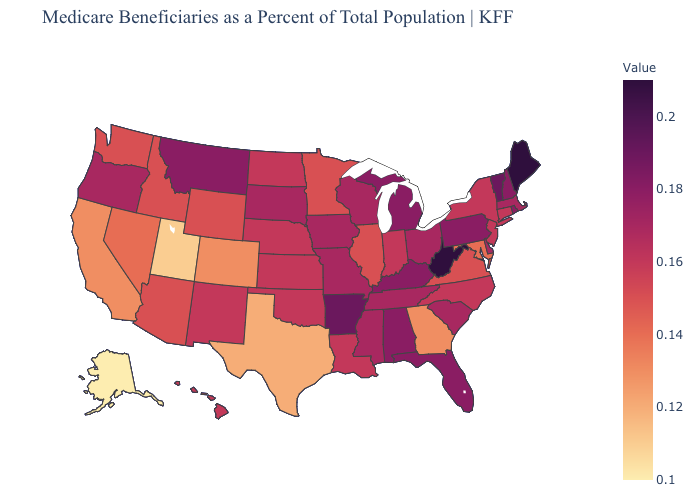Does Indiana have a higher value than Arkansas?
Concise answer only. No. Among the states that border Kentucky , does Ohio have the lowest value?
Answer briefly. No. Among the states that border Arizona , which have the highest value?
Concise answer only. New Mexico. Does the map have missing data?
Be succinct. No. Which states have the lowest value in the USA?
Write a very short answer. Alaska. Among the states that border North Dakota , does Montana have the highest value?
Keep it brief. Yes. 